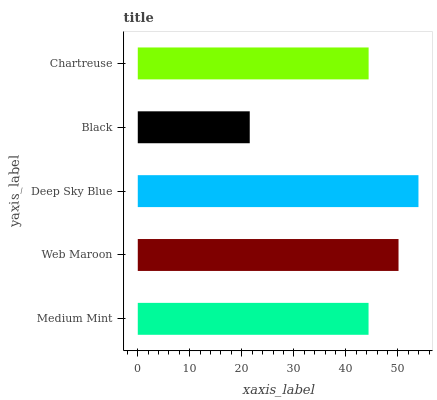Is Black the minimum?
Answer yes or no. Yes. Is Deep Sky Blue the maximum?
Answer yes or no. Yes. Is Web Maroon the minimum?
Answer yes or no. No. Is Web Maroon the maximum?
Answer yes or no. No. Is Web Maroon greater than Medium Mint?
Answer yes or no. Yes. Is Medium Mint less than Web Maroon?
Answer yes or no. Yes. Is Medium Mint greater than Web Maroon?
Answer yes or no. No. Is Web Maroon less than Medium Mint?
Answer yes or no. No. Is Chartreuse the high median?
Answer yes or no. Yes. Is Chartreuse the low median?
Answer yes or no. Yes. Is Web Maroon the high median?
Answer yes or no. No. Is Black the low median?
Answer yes or no. No. 